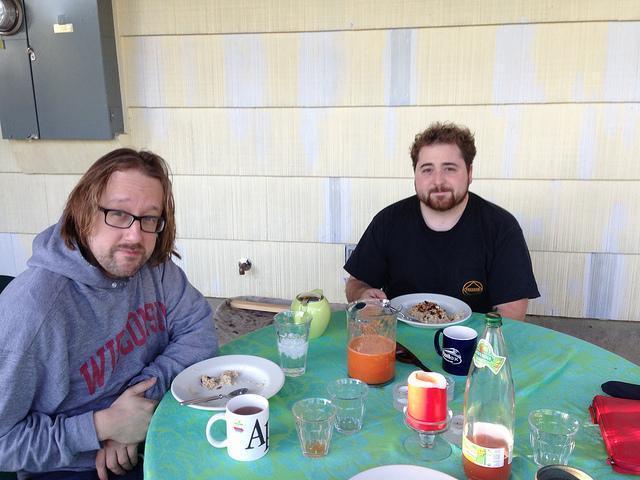How many people are wearing glasses?
Give a very brief answer. 1. How many people are there?
Give a very brief answer. 2. How many cups can you see?
Give a very brief answer. 3. 